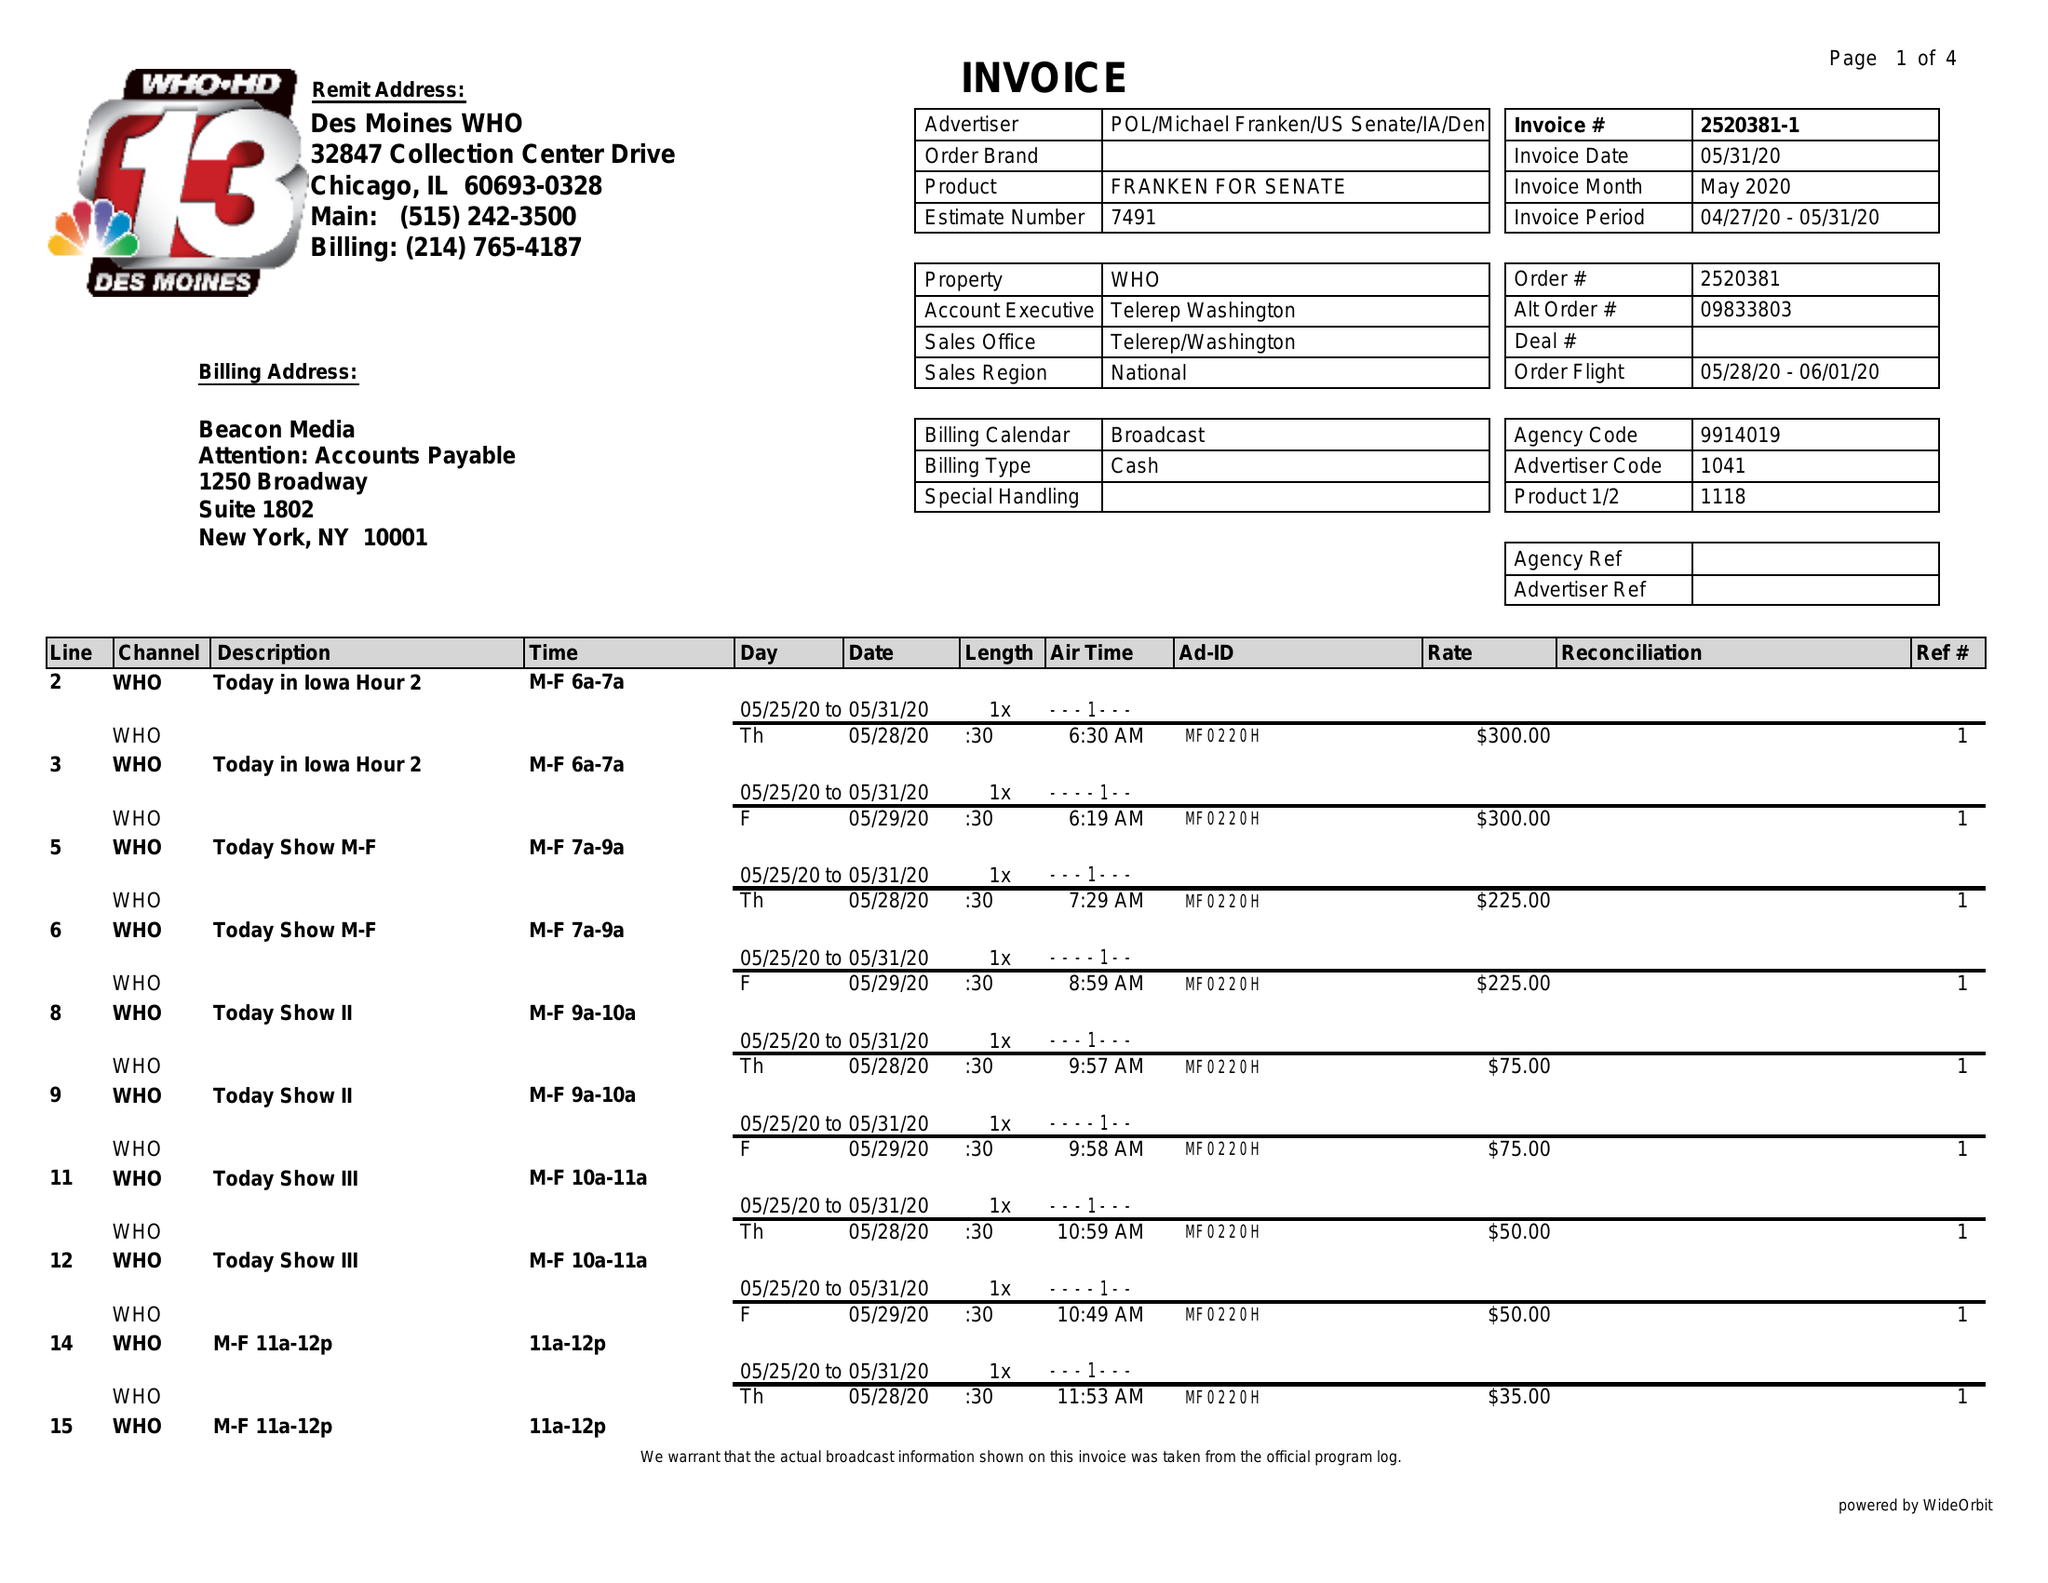What is the value for the flight_from?
Answer the question using a single word or phrase. 05/28/20 